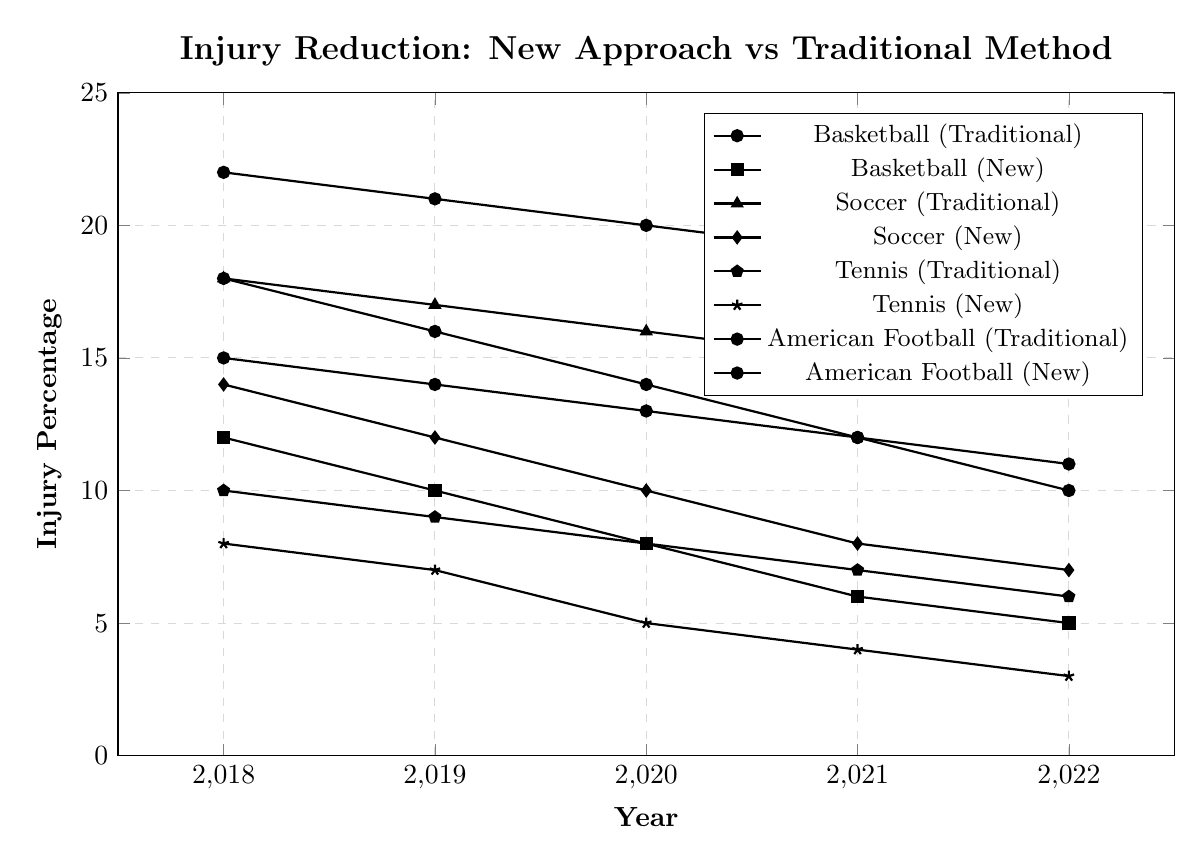Which sport had the highest injury percentage using the traditional method in 2022? Look at the data for 2022 for all sports using the traditional method. The values are Basketball (11), Soccer (14), Tennis (6), and American Football (18). American Football has the highest value.
Answer: American Football How many years did Basketball see a reduction in injury percentages with the new approach compared to the previous year? Examine the Basketball injury percentages under the new approach from 2018 to 2022: (2018, 12) (2019, 10) (2020, 8) (2021, 6) (2022, 5). Each year is lower than the previous, totaling 4 years of reduction.
Answer: 4 Which sport saw the biggest decrease in injury percentages from the traditional method to the new approach in 2022? Compare the difference between the traditional method and the new approach in 2022 for each sport: Basketball (6), Soccer (7), Tennis (3), and American Football (8). The biggest decrease is for American Football.
Answer: American Football What's the combined injury percentage reduction for Soccer from 2018 to 2019 under the new approach compared to the traditional method? Calculate the difference between the traditional method and the new approach for Soccer in 2018 (18-14=4) and in 2019 (17-12=5). Add these two differences: 4 + 5 = 9.
Answer: 9 By what percentage did Tennis injury percentages reduce from the traditional method to the new approach in 2020? Find the 2020 values for Tennis: (traditional method, 8) and (new approach, 5). Calculate the percentage decrease: ((8-5)/8) * 100 = 37.5%.
Answer: 37.5% Which sport has the most consistent reduction in injury percentages with the new approach over the five years? Compare the data for all sports using the new approach from 2018 to 2022 and see the reductions: Basketball (12 to 5), Soccer (14 to 7), Tennis (8 to 3), and American Football (18 to 10). Tennis has a consistently close reduction in numbers each year.
Answer: Tennis In 2021, which sport had a greater reduction in injury percentage with the new approach compared to the traditional method: Basketball or Soccer? For 2021, compare the differences: Basketball (12-6=6) and Soccer (15-8=7). Soccer had a greater reduction.
Answer: Soccer What is the overall average injury percentage for Basketball using the traditional method from 2018 to 2022? Add the injury percentages for Basketball from 2018 to 2022 using the traditional method: 15 + 14 + 13 + 12 + 11 = 65. Then divide by the number of years: 65/5= 13.
Answer: 13 How many years did American Football show a reduction in injury percentage using the new approach compared to the previous year? Check the injury percentages for American Football under the new approach: (2018, 18), (2019, 16), (2020, 14), (2021, 12), (2022, 10). Each year shows a reduction from the previous year, so there are 4 years in total.
Answer: 4 